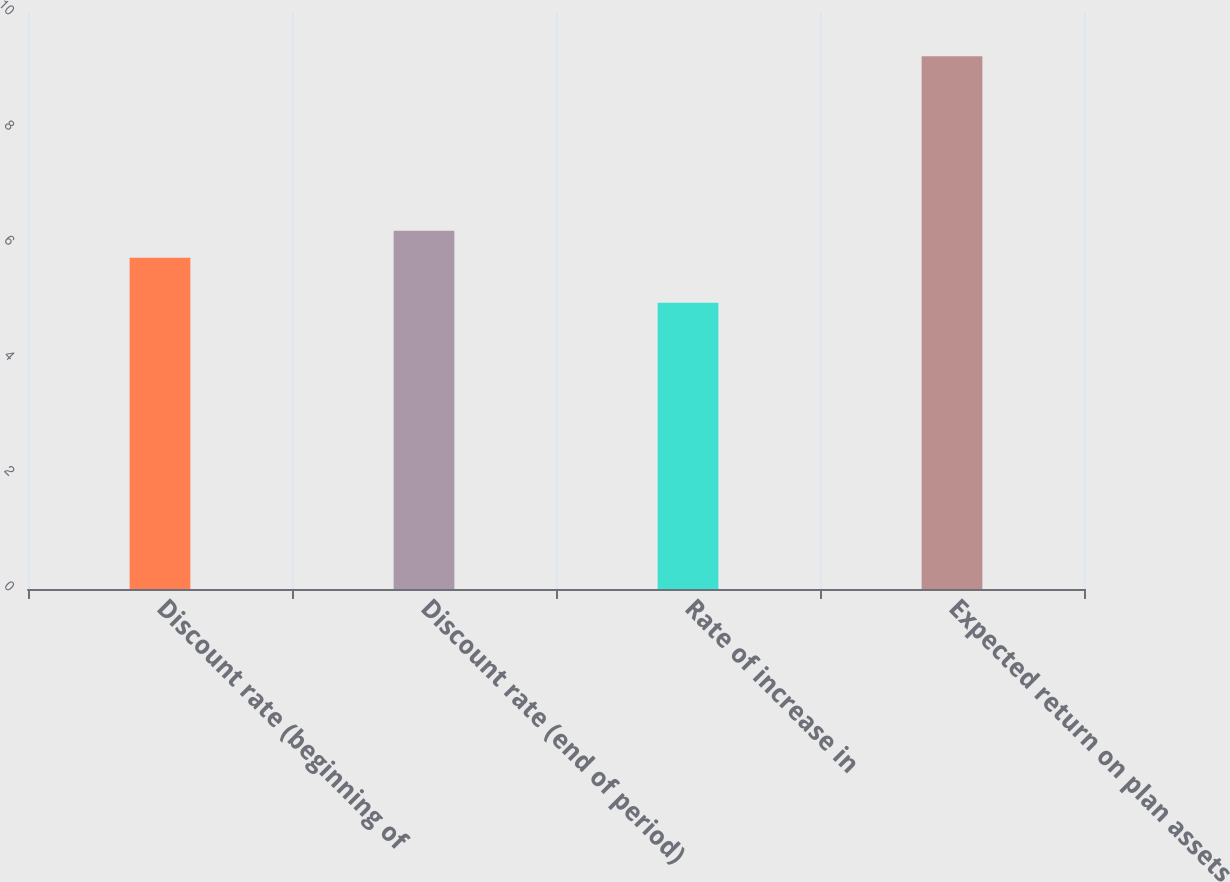Convert chart. <chart><loc_0><loc_0><loc_500><loc_500><bar_chart><fcel>Discount rate (beginning of<fcel>Discount rate (end of period)<fcel>Rate of increase in<fcel>Expected return on plan assets<nl><fcel>5.75<fcel>6.22<fcel>4.97<fcel>9.25<nl></chart> 